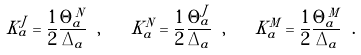Convert formula to latex. <formula><loc_0><loc_0><loc_500><loc_500>K _ { a } ^ { J } = \frac { 1 } { 2 } \frac { \Theta _ { a } ^ { N } } { \Delta _ { a } } \ , \quad K _ { a } ^ { N } = \frac { 1 } { 2 } \frac { \Theta _ { a } ^ { J } } { \Delta _ { a } } \ , \quad K _ { a } ^ { M } = \frac { 1 } { 2 } \frac { \Theta _ { a } ^ { M } } { \Delta _ { a } } \ .</formula> 